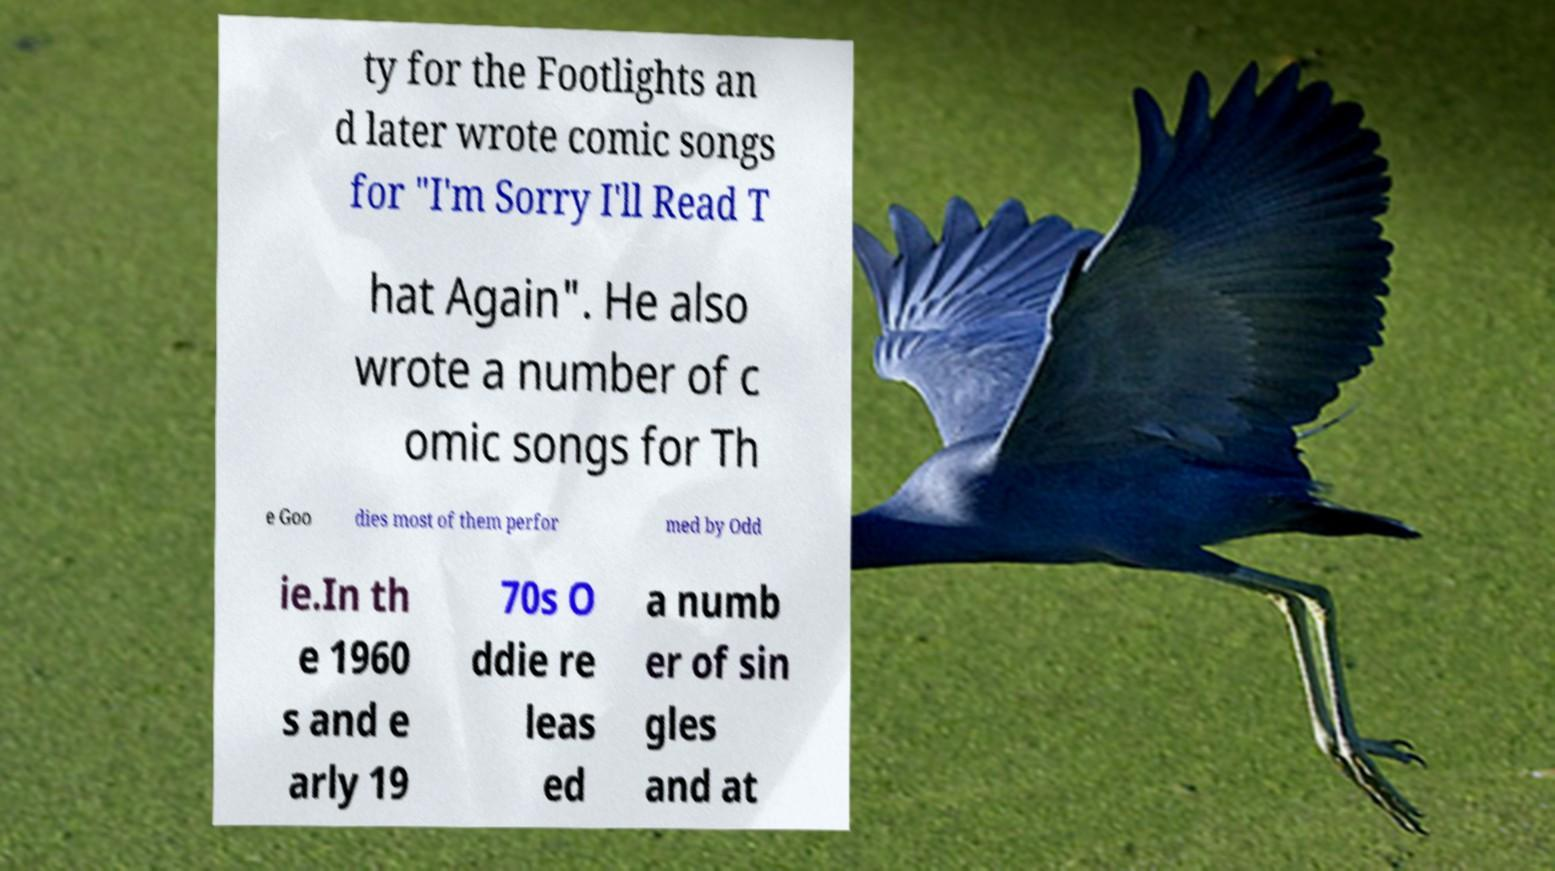Can you read and provide the text displayed in the image?This photo seems to have some interesting text. Can you extract and type it out for me? ty for the Footlights an d later wrote comic songs for "I'm Sorry I'll Read T hat Again". He also wrote a number of c omic songs for Th e Goo dies most of them perfor med by Odd ie.In th e 1960 s and e arly 19 70s O ddie re leas ed a numb er of sin gles and at 